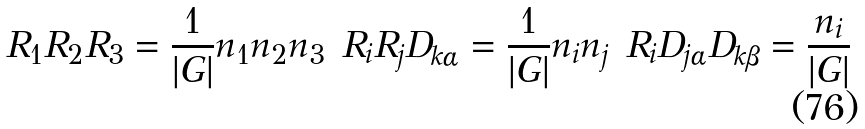Convert formula to latex. <formula><loc_0><loc_0><loc_500><loc_500>R _ { 1 } R _ { 2 } R _ { 3 } & = \frac { 1 } { | G | } n _ { 1 } n _ { 2 } n _ { 3 } & R _ { i } R _ { j } D _ { k \alpha } & = \frac { 1 } { | G | } n _ { i } n _ { j } & R _ { i } D _ { j \alpha } D _ { k \beta } = \frac { n _ { i } } { | G | }</formula> 